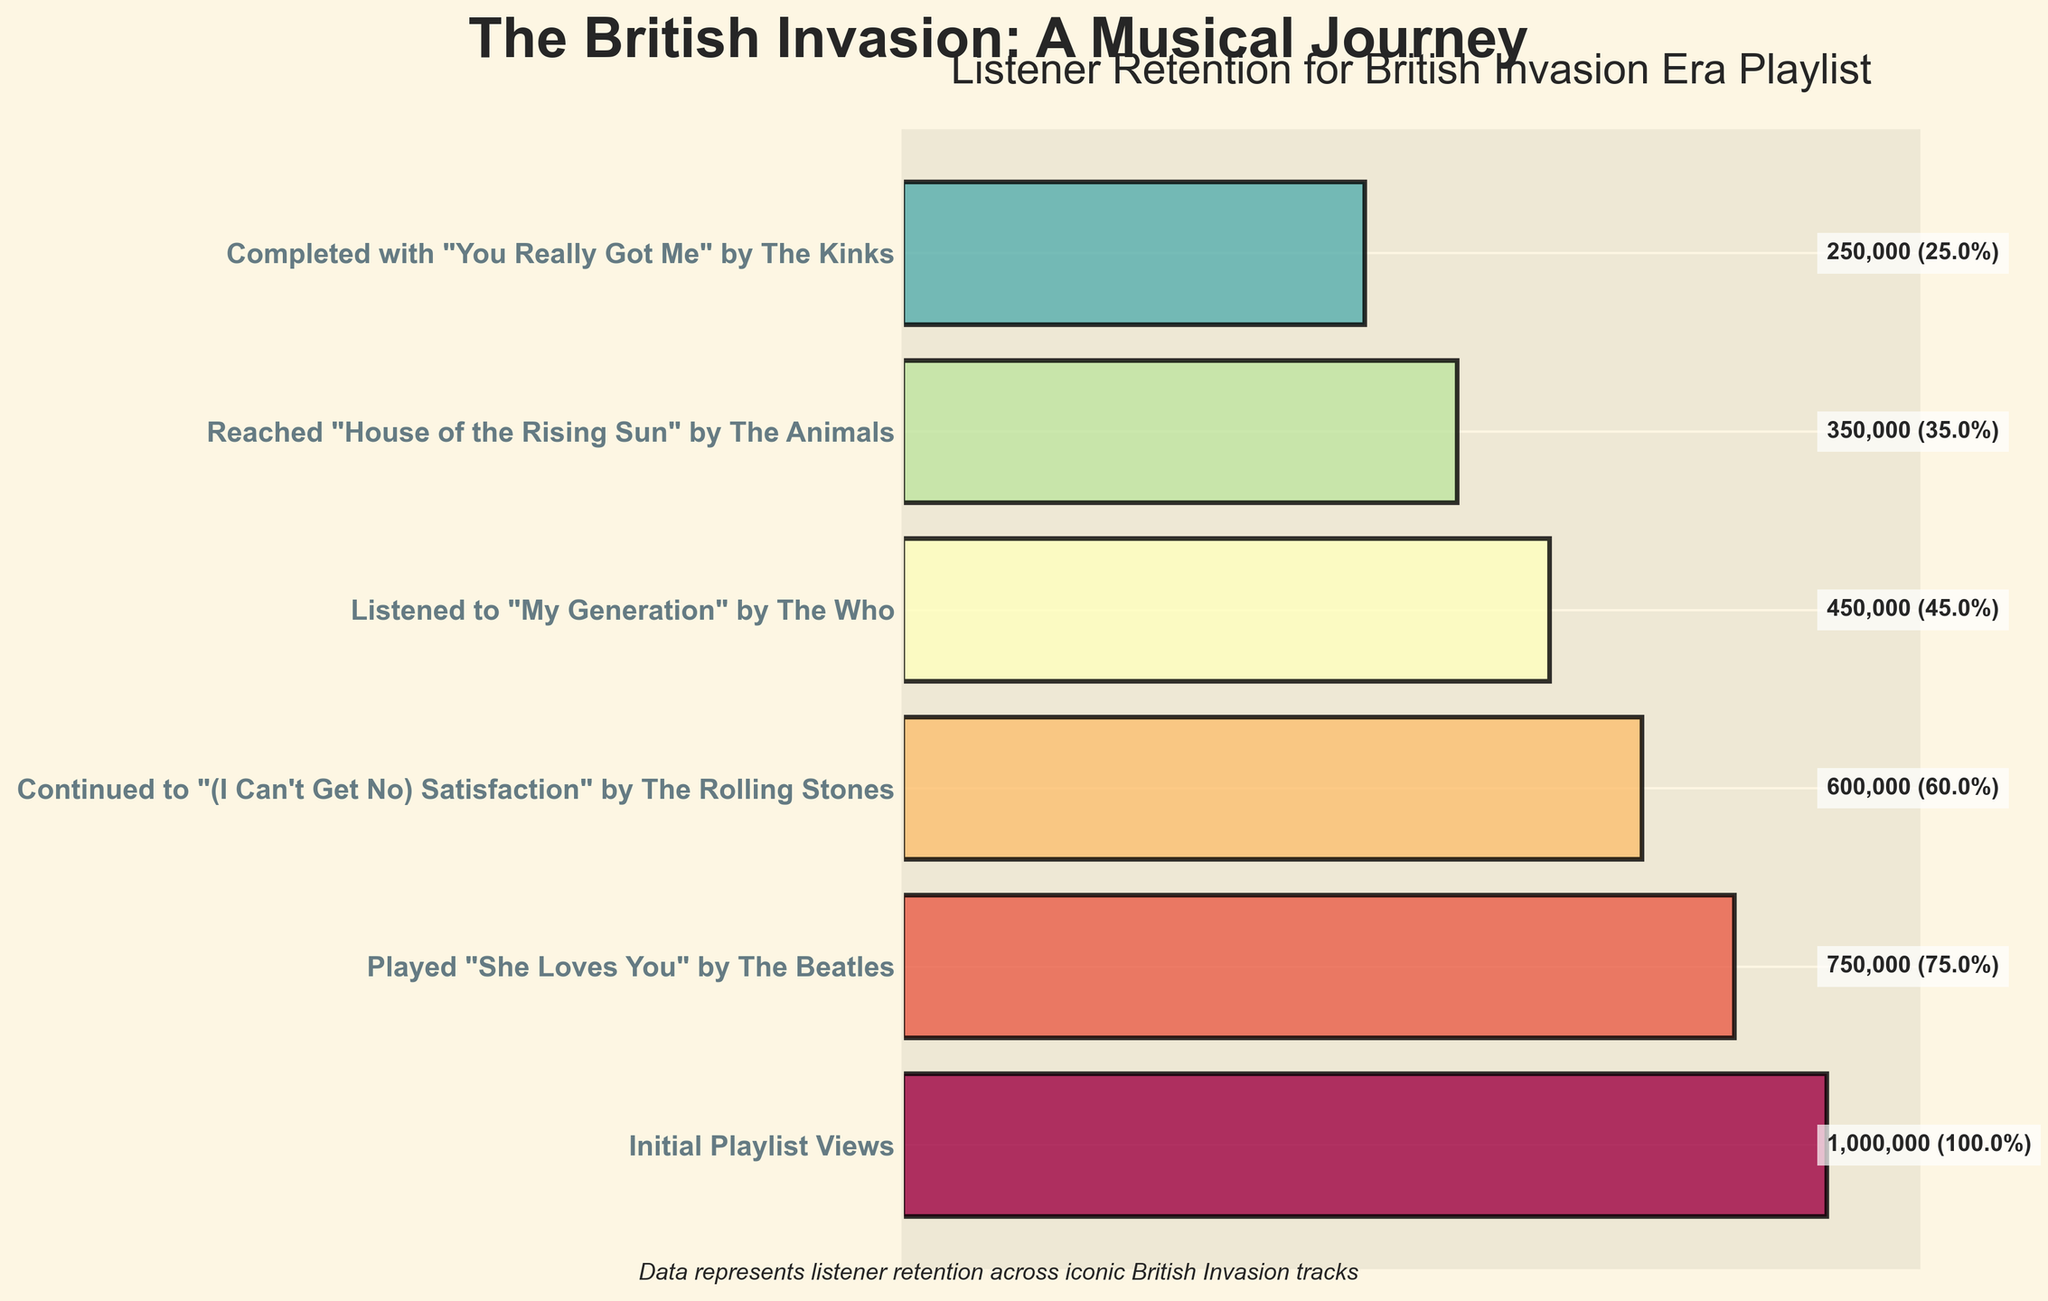What is the title of the funnel chart? The title of the funnel chart is located at the top and it reads "The British Invasion: A Musical Journey."
Answer: "The British Invasion: A Musical Journey" How many initial playlist views were there? The initial playlist views are indicated at the top of the funnel and it shows the number as 1,000,000.
Answer: 1,000,000 What song is played at the second stage of the funnel? The second stage of the funnel states "Played 'She Loves You' by The Beatles."
Answer: "She Loves You" by The Beatles How many listeners completed the playlist? The final stage of the funnel, which represents the end of the playlist, shows that 250,000 listeners completed the playlist.
Answer: 250,000 What percentage of the initial viewers listened to "My Generation" by The Who? The number of listeners at this stage is 450,000. The percentage can be calculated as (450,000/1,000,000) * 100 = 45%.
Answer: 45% Compare the number of listeners of "She Loves You" by The Beatles and "(I Can't Get No) Satisfaction" by The Rolling Stones. Which has more listeners? "She Loves You" by The Beatles has 750,000 listeners and "(I Can't Get No) Satisfaction" by The Rolling Stones has 600,000 listeners, so "She Loves You" has more listeners.
Answer: "She Loves You" by The Beatles How many listeners did not continue after listening to "My Generation" by The Who? The number of listeners who listened to "My Generation" is 450,000, and the listeners who continued to the next stage are 350,000. The difference is 450,000 - 350,000 = 100,000 listeners did not continue.
Answer: 100,000 What is the drop in number of listeners from "Played 'She Loves You' by The Beatles" to "Continued to '(I Can't Get No) Satisfaction' by The Rolling Stones"? The number of listeners drops from 750,000 to 600,000. The difference is 750,000 - 600,000 = 150,000.
Answer: 150,000 What is the percentage retention from "Reached 'House of the Rising Sun' by The Animals" to "Completed with 'You Really Got Me' by The Kinks"? The listeners for "House of the Rising Sun" are 350,000, and the final stage has 250,000 listeners. The retention percentage is (250,000/350,000) * 100 = 71.4%.
Answer: 71.4% How many stages overall are shown in the funnel chart? There are labels for each stage along the y-axis, starting from the initial views to the final song. Counting these labels, there are 6 stages in total.
Answer: 6 